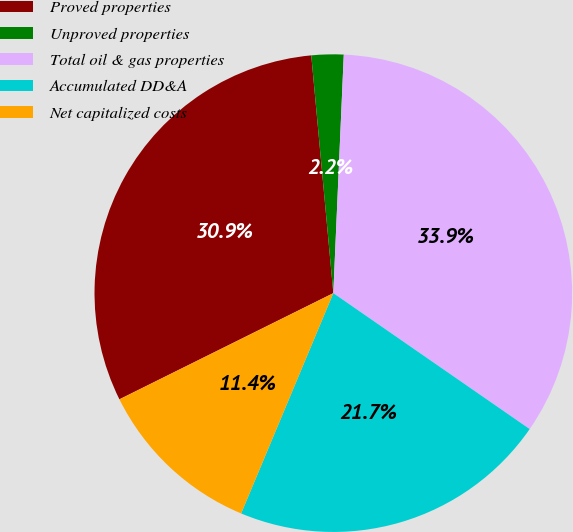<chart> <loc_0><loc_0><loc_500><loc_500><pie_chart><fcel>Proved properties<fcel>Unproved properties<fcel>Total oil & gas properties<fcel>Accumulated DD&A<fcel>Net capitalized costs<nl><fcel>30.86%<fcel>2.17%<fcel>33.94%<fcel>21.67%<fcel>11.36%<nl></chart> 